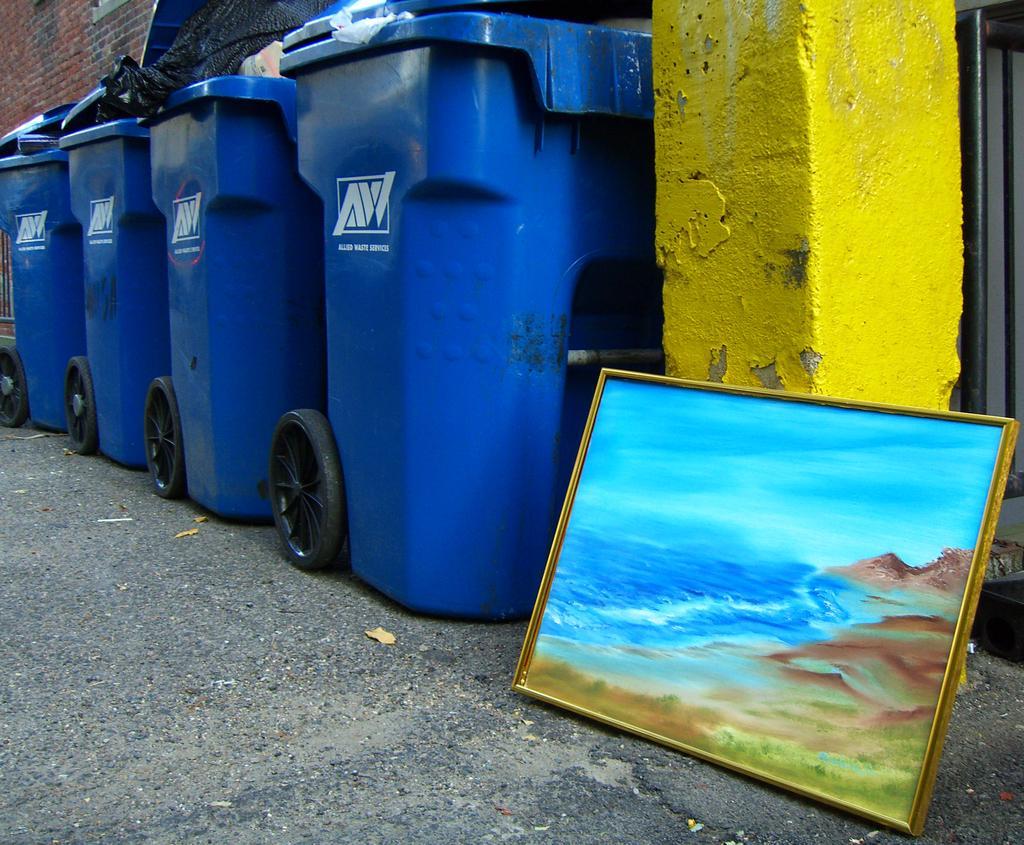Could you give a brief overview of what you see in this image? On the right side there is a yellow pillar. Near to that there is a painting with frame. Also there are waste boxes. In the back there is a brick wall. 